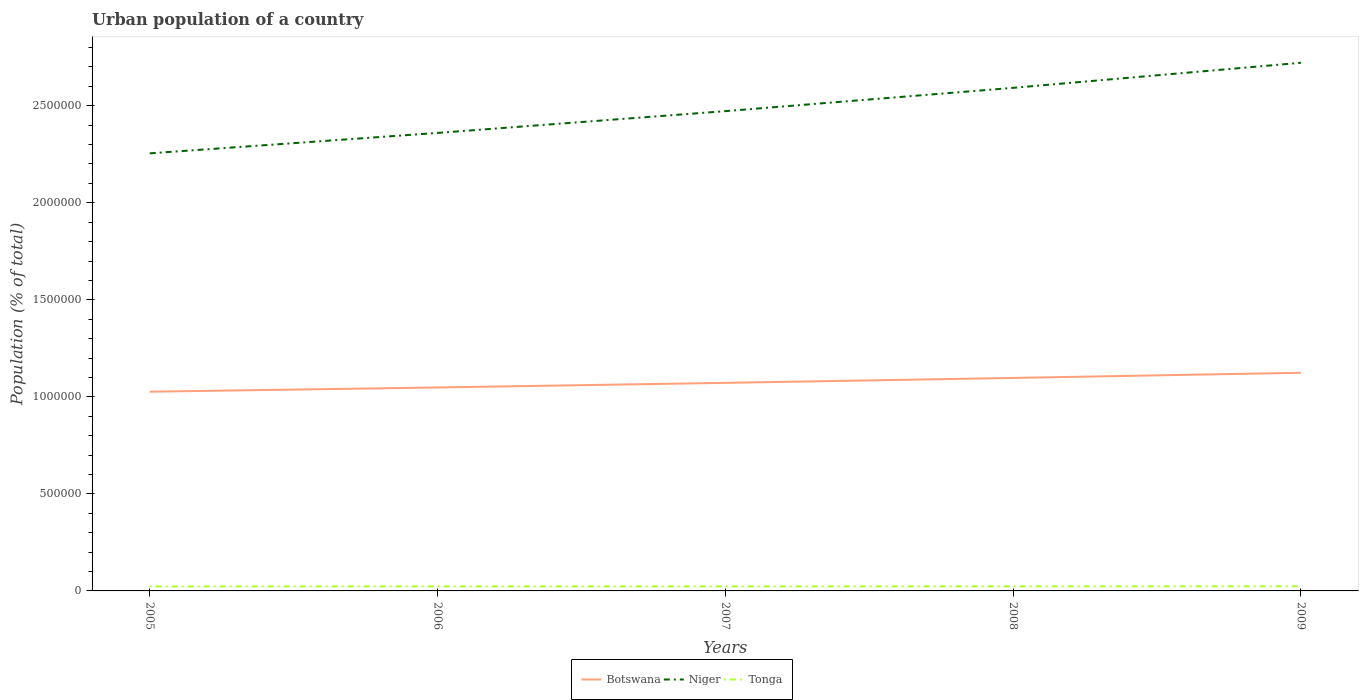Is the number of lines equal to the number of legend labels?
Your response must be concise. Yes. Across all years, what is the maximum urban population in Botswana?
Ensure brevity in your answer.  1.03e+06. In which year was the urban population in Botswana maximum?
Offer a terse response. 2005. What is the total urban population in Tonga in the graph?
Ensure brevity in your answer.  -179. What is the difference between the highest and the second highest urban population in Niger?
Your answer should be very brief. 4.67e+05. What is the difference between two consecutive major ticks on the Y-axis?
Ensure brevity in your answer.  5.00e+05. Are the values on the major ticks of Y-axis written in scientific E-notation?
Keep it short and to the point. No. Does the graph contain any zero values?
Keep it short and to the point. No. Where does the legend appear in the graph?
Offer a terse response. Bottom center. How many legend labels are there?
Ensure brevity in your answer.  3. How are the legend labels stacked?
Provide a succinct answer. Horizontal. What is the title of the graph?
Offer a terse response. Urban population of a country. Does "Latvia" appear as one of the legend labels in the graph?
Make the answer very short. No. What is the label or title of the Y-axis?
Give a very brief answer. Population (% of total). What is the Population (% of total) of Botswana in 2005?
Provide a succinct answer. 1.03e+06. What is the Population (% of total) in Niger in 2005?
Offer a terse response. 2.25e+06. What is the Population (% of total) in Tonga in 2005?
Your answer should be very brief. 2.34e+04. What is the Population (% of total) of Botswana in 2006?
Your answer should be very brief. 1.05e+06. What is the Population (% of total) of Niger in 2006?
Provide a short and direct response. 2.36e+06. What is the Population (% of total) in Tonga in 2006?
Offer a terse response. 2.35e+04. What is the Population (% of total) of Botswana in 2007?
Provide a short and direct response. 1.07e+06. What is the Population (% of total) of Niger in 2007?
Make the answer very short. 2.47e+06. What is the Population (% of total) in Tonga in 2007?
Your answer should be compact. 2.37e+04. What is the Population (% of total) in Botswana in 2008?
Your response must be concise. 1.10e+06. What is the Population (% of total) of Niger in 2008?
Give a very brief answer. 2.59e+06. What is the Population (% of total) in Tonga in 2008?
Provide a succinct answer. 2.39e+04. What is the Population (% of total) in Botswana in 2009?
Keep it short and to the point. 1.12e+06. What is the Population (% of total) in Niger in 2009?
Give a very brief answer. 2.72e+06. What is the Population (% of total) in Tonga in 2009?
Ensure brevity in your answer.  2.41e+04. Across all years, what is the maximum Population (% of total) in Botswana?
Your answer should be compact. 1.12e+06. Across all years, what is the maximum Population (% of total) of Niger?
Make the answer very short. 2.72e+06. Across all years, what is the maximum Population (% of total) in Tonga?
Your response must be concise. 2.41e+04. Across all years, what is the minimum Population (% of total) of Botswana?
Give a very brief answer. 1.03e+06. Across all years, what is the minimum Population (% of total) of Niger?
Keep it short and to the point. 2.25e+06. Across all years, what is the minimum Population (% of total) in Tonga?
Offer a very short reply. 2.34e+04. What is the total Population (% of total) in Botswana in the graph?
Keep it short and to the point. 5.37e+06. What is the total Population (% of total) in Niger in the graph?
Your response must be concise. 1.24e+07. What is the total Population (% of total) in Tonga in the graph?
Your answer should be compact. 1.19e+05. What is the difference between the Population (% of total) of Botswana in 2005 and that in 2006?
Provide a short and direct response. -2.19e+04. What is the difference between the Population (% of total) in Niger in 2005 and that in 2006?
Your response must be concise. -1.05e+05. What is the difference between the Population (% of total) of Tonga in 2005 and that in 2006?
Your response must be concise. -179. What is the difference between the Population (% of total) in Botswana in 2005 and that in 2007?
Your answer should be compact. -4.56e+04. What is the difference between the Population (% of total) of Niger in 2005 and that in 2007?
Ensure brevity in your answer.  -2.18e+05. What is the difference between the Population (% of total) in Tonga in 2005 and that in 2007?
Keep it short and to the point. -377. What is the difference between the Population (% of total) in Botswana in 2005 and that in 2008?
Make the answer very short. -7.10e+04. What is the difference between the Population (% of total) in Niger in 2005 and that in 2008?
Make the answer very short. -3.38e+05. What is the difference between the Population (% of total) in Tonga in 2005 and that in 2008?
Give a very brief answer. -583. What is the difference between the Population (% of total) in Botswana in 2005 and that in 2009?
Your response must be concise. -9.76e+04. What is the difference between the Population (% of total) of Niger in 2005 and that in 2009?
Give a very brief answer. -4.67e+05. What is the difference between the Population (% of total) of Tonga in 2005 and that in 2009?
Make the answer very short. -778. What is the difference between the Population (% of total) of Botswana in 2006 and that in 2007?
Your response must be concise. -2.37e+04. What is the difference between the Population (% of total) in Niger in 2006 and that in 2007?
Give a very brief answer. -1.12e+05. What is the difference between the Population (% of total) of Tonga in 2006 and that in 2007?
Provide a succinct answer. -198. What is the difference between the Population (% of total) of Botswana in 2006 and that in 2008?
Your answer should be very brief. -4.91e+04. What is the difference between the Population (% of total) of Niger in 2006 and that in 2008?
Offer a terse response. -2.32e+05. What is the difference between the Population (% of total) in Tonga in 2006 and that in 2008?
Keep it short and to the point. -404. What is the difference between the Population (% of total) in Botswana in 2006 and that in 2009?
Provide a succinct answer. -7.57e+04. What is the difference between the Population (% of total) in Niger in 2006 and that in 2009?
Give a very brief answer. -3.62e+05. What is the difference between the Population (% of total) of Tonga in 2006 and that in 2009?
Provide a succinct answer. -599. What is the difference between the Population (% of total) in Botswana in 2007 and that in 2008?
Your answer should be very brief. -2.54e+04. What is the difference between the Population (% of total) of Niger in 2007 and that in 2008?
Your answer should be very brief. -1.20e+05. What is the difference between the Population (% of total) in Tonga in 2007 and that in 2008?
Keep it short and to the point. -206. What is the difference between the Population (% of total) in Botswana in 2007 and that in 2009?
Your answer should be compact. -5.20e+04. What is the difference between the Population (% of total) of Niger in 2007 and that in 2009?
Keep it short and to the point. -2.49e+05. What is the difference between the Population (% of total) in Tonga in 2007 and that in 2009?
Provide a short and direct response. -401. What is the difference between the Population (% of total) of Botswana in 2008 and that in 2009?
Provide a succinct answer. -2.66e+04. What is the difference between the Population (% of total) in Niger in 2008 and that in 2009?
Offer a terse response. -1.29e+05. What is the difference between the Population (% of total) in Tonga in 2008 and that in 2009?
Provide a short and direct response. -195. What is the difference between the Population (% of total) of Botswana in 2005 and the Population (% of total) of Niger in 2006?
Ensure brevity in your answer.  -1.33e+06. What is the difference between the Population (% of total) in Botswana in 2005 and the Population (% of total) in Tonga in 2006?
Ensure brevity in your answer.  1.00e+06. What is the difference between the Population (% of total) in Niger in 2005 and the Population (% of total) in Tonga in 2006?
Make the answer very short. 2.23e+06. What is the difference between the Population (% of total) in Botswana in 2005 and the Population (% of total) in Niger in 2007?
Provide a succinct answer. -1.45e+06. What is the difference between the Population (% of total) in Botswana in 2005 and the Population (% of total) in Tonga in 2007?
Your response must be concise. 1.00e+06. What is the difference between the Population (% of total) in Niger in 2005 and the Population (% of total) in Tonga in 2007?
Your answer should be compact. 2.23e+06. What is the difference between the Population (% of total) in Botswana in 2005 and the Population (% of total) in Niger in 2008?
Ensure brevity in your answer.  -1.57e+06. What is the difference between the Population (% of total) in Botswana in 2005 and the Population (% of total) in Tonga in 2008?
Provide a succinct answer. 1.00e+06. What is the difference between the Population (% of total) in Niger in 2005 and the Population (% of total) in Tonga in 2008?
Offer a terse response. 2.23e+06. What is the difference between the Population (% of total) in Botswana in 2005 and the Population (% of total) in Niger in 2009?
Give a very brief answer. -1.70e+06. What is the difference between the Population (% of total) in Botswana in 2005 and the Population (% of total) in Tonga in 2009?
Provide a short and direct response. 1.00e+06. What is the difference between the Population (% of total) of Niger in 2005 and the Population (% of total) of Tonga in 2009?
Offer a very short reply. 2.23e+06. What is the difference between the Population (% of total) in Botswana in 2006 and the Population (% of total) in Niger in 2007?
Give a very brief answer. -1.42e+06. What is the difference between the Population (% of total) in Botswana in 2006 and the Population (% of total) in Tonga in 2007?
Your answer should be very brief. 1.02e+06. What is the difference between the Population (% of total) of Niger in 2006 and the Population (% of total) of Tonga in 2007?
Ensure brevity in your answer.  2.34e+06. What is the difference between the Population (% of total) of Botswana in 2006 and the Population (% of total) of Niger in 2008?
Provide a succinct answer. -1.54e+06. What is the difference between the Population (% of total) of Botswana in 2006 and the Population (% of total) of Tonga in 2008?
Provide a succinct answer. 1.02e+06. What is the difference between the Population (% of total) of Niger in 2006 and the Population (% of total) of Tonga in 2008?
Provide a succinct answer. 2.34e+06. What is the difference between the Population (% of total) in Botswana in 2006 and the Population (% of total) in Niger in 2009?
Provide a succinct answer. -1.67e+06. What is the difference between the Population (% of total) in Botswana in 2006 and the Population (% of total) in Tonga in 2009?
Offer a very short reply. 1.02e+06. What is the difference between the Population (% of total) in Niger in 2006 and the Population (% of total) in Tonga in 2009?
Your answer should be compact. 2.34e+06. What is the difference between the Population (% of total) of Botswana in 2007 and the Population (% of total) of Niger in 2008?
Provide a succinct answer. -1.52e+06. What is the difference between the Population (% of total) in Botswana in 2007 and the Population (% of total) in Tonga in 2008?
Offer a very short reply. 1.05e+06. What is the difference between the Population (% of total) in Niger in 2007 and the Population (% of total) in Tonga in 2008?
Your answer should be very brief. 2.45e+06. What is the difference between the Population (% of total) of Botswana in 2007 and the Population (% of total) of Niger in 2009?
Your answer should be compact. -1.65e+06. What is the difference between the Population (% of total) in Botswana in 2007 and the Population (% of total) in Tonga in 2009?
Give a very brief answer. 1.05e+06. What is the difference between the Population (% of total) in Niger in 2007 and the Population (% of total) in Tonga in 2009?
Provide a succinct answer. 2.45e+06. What is the difference between the Population (% of total) in Botswana in 2008 and the Population (% of total) in Niger in 2009?
Provide a succinct answer. -1.62e+06. What is the difference between the Population (% of total) of Botswana in 2008 and the Population (% of total) of Tonga in 2009?
Give a very brief answer. 1.07e+06. What is the difference between the Population (% of total) in Niger in 2008 and the Population (% of total) in Tonga in 2009?
Make the answer very short. 2.57e+06. What is the average Population (% of total) of Botswana per year?
Your answer should be very brief. 1.07e+06. What is the average Population (% of total) of Niger per year?
Your answer should be compact. 2.48e+06. What is the average Population (% of total) in Tonga per year?
Your response must be concise. 2.37e+04. In the year 2005, what is the difference between the Population (% of total) in Botswana and Population (% of total) in Niger?
Ensure brevity in your answer.  -1.23e+06. In the year 2005, what is the difference between the Population (% of total) of Botswana and Population (% of total) of Tonga?
Keep it short and to the point. 1.00e+06. In the year 2005, what is the difference between the Population (% of total) in Niger and Population (% of total) in Tonga?
Offer a terse response. 2.23e+06. In the year 2006, what is the difference between the Population (% of total) in Botswana and Population (% of total) in Niger?
Your answer should be very brief. -1.31e+06. In the year 2006, what is the difference between the Population (% of total) of Botswana and Population (% of total) of Tonga?
Ensure brevity in your answer.  1.02e+06. In the year 2006, what is the difference between the Population (% of total) in Niger and Population (% of total) in Tonga?
Give a very brief answer. 2.34e+06. In the year 2007, what is the difference between the Population (% of total) in Botswana and Population (% of total) in Niger?
Give a very brief answer. -1.40e+06. In the year 2007, what is the difference between the Population (% of total) in Botswana and Population (% of total) in Tonga?
Provide a succinct answer. 1.05e+06. In the year 2007, what is the difference between the Population (% of total) of Niger and Population (% of total) of Tonga?
Ensure brevity in your answer.  2.45e+06. In the year 2008, what is the difference between the Population (% of total) of Botswana and Population (% of total) of Niger?
Offer a very short reply. -1.49e+06. In the year 2008, what is the difference between the Population (% of total) in Botswana and Population (% of total) in Tonga?
Ensure brevity in your answer.  1.07e+06. In the year 2008, what is the difference between the Population (% of total) in Niger and Population (% of total) in Tonga?
Your answer should be compact. 2.57e+06. In the year 2009, what is the difference between the Population (% of total) in Botswana and Population (% of total) in Niger?
Your answer should be very brief. -1.60e+06. In the year 2009, what is the difference between the Population (% of total) of Botswana and Population (% of total) of Tonga?
Provide a succinct answer. 1.10e+06. In the year 2009, what is the difference between the Population (% of total) in Niger and Population (% of total) in Tonga?
Offer a terse response. 2.70e+06. What is the ratio of the Population (% of total) of Botswana in 2005 to that in 2006?
Ensure brevity in your answer.  0.98. What is the ratio of the Population (% of total) in Niger in 2005 to that in 2006?
Offer a terse response. 0.96. What is the ratio of the Population (% of total) of Tonga in 2005 to that in 2006?
Provide a short and direct response. 0.99. What is the ratio of the Population (% of total) in Botswana in 2005 to that in 2007?
Ensure brevity in your answer.  0.96. What is the ratio of the Population (% of total) of Niger in 2005 to that in 2007?
Your response must be concise. 0.91. What is the ratio of the Population (% of total) in Tonga in 2005 to that in 2007?
Give a very brief answer. 0.98. What is the ratio of the Population (% of total) of Botswana in 2005 to that in 2008?
Provide a succinct answer. 0.94. What is the ratio of the Population (% of total) of Niger in 2005 to that in 2008?
Your answer should be very brief. 0.87. What is the ratio of the Population (% of total) of Tonga in 2005 to that in 2008?
Ensure brevity in your answer.  0.98. What is the ratio of the Population (% of total) of Botswana in 2005 to that in 2009?
Your response must be concise. 0.91. What is the ratio of the Population (% of total) of Niger in 2005 to that in 2009?
Your answer should be compact. 0.83. What is the ratio of the Population (% of total) of Tonga in 2005 to that in 2009?
Provide a short and direct response. 0.97. What is the ratio of the Population (% of total) of Botswana in 2006 to that in 2007?
Offer a very short reply. 0.98. What is the ratio of the Population (% of total) of Niger in 2006 to that in 2007?
Give a very brief answer. 0.95. What is the ratio of the Population (% of total) of Botswana in 2006 to that in 2008?
Your response must be concise. 0.96. What is the ratio of the Population (% of total) in Niger in 2006 to that in 2008?
Provide a succinct answer. 0.91. What is the ratio of the Population (% of total) in Tonga in 2006 to that in 2008?
Your answer should be very brief. 0.98. What is the ratio of the Population (% of total) in Botswana in 2006 to that in 2009?
Give a very brief answer. 0.93. What is the ratio of the Population (% of total) in Niger in 2006 to that in 2009?
Provide a short and direct response. 0.87. What is the ratio of the Population (% of total) in Tonga in 2006 to that in 2009?
Your answer should be compact. 0.98. What is the ratio of the Population (% of total) of Botswana in 2007 to that in 2008?
Give a very brief answer. 0.98. What is the ratio of the Population (% of total) in Niger in 2007 to that in 2008?
Ensure brevity in your answer.  0.95. What is the ratio of the Population (% of total) of Tonga in 2007 to that in 2008?
Make the answer very short. 0.99. What is the ratio of the Population (% of total) in Botswana in 2007 to that in 2009?
Keep it short and to the point. 0.95. What is the ratio of the Population (% of total) of Niger in 2007 to that in 2009?
Give a very brief answer. 0.91. What is the ratio of the Population (% of total) of Tonga in 2007 to that in 2009?
Your answer should be very brief. 0.98. What is the ratio of the Population (% of total) of Botswana in 2008 to that in 2009?
Keep it short and to the point. 0.98. What is the ratio of the Population (% of total) of Niger in 2008 to that in 2009?
Your answer should be compact. 0.95. What is the ratio of the Population (% of total) in Tonga in 2008 to that in 2009?
Ensure brevity in your answer.  0.99. What is the difference between the highest and the second highest Population (% of total) in Botswana?
Provide a short and direct response. 2.66e+04. What is the difference between the highest and the second highest Population (% of total) in Niger?
Offer a very short reply. 1.29e+05. What is the difference between the highest and the second highest Population (% of total) in Tonga?
Make the answer very short. 195. What is the difference between the highest and the lowest Population (% of total) in Botswana?
Give a very brief answer. 9.76e+04. What is the difference between the highest and the lowest Population (% of total) in Niger?
Ensure brevity in your answer.  4.67e+05. What is the difference between the highest and the lowest Population (% of total) of Tonga?
Provide a short and direct response. 778. 